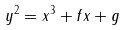<formula> <loc_0><loc_0><loc_500><loc_500>y ^ { 2 } = x ^ { 3 } + f x + g \,</formula> 